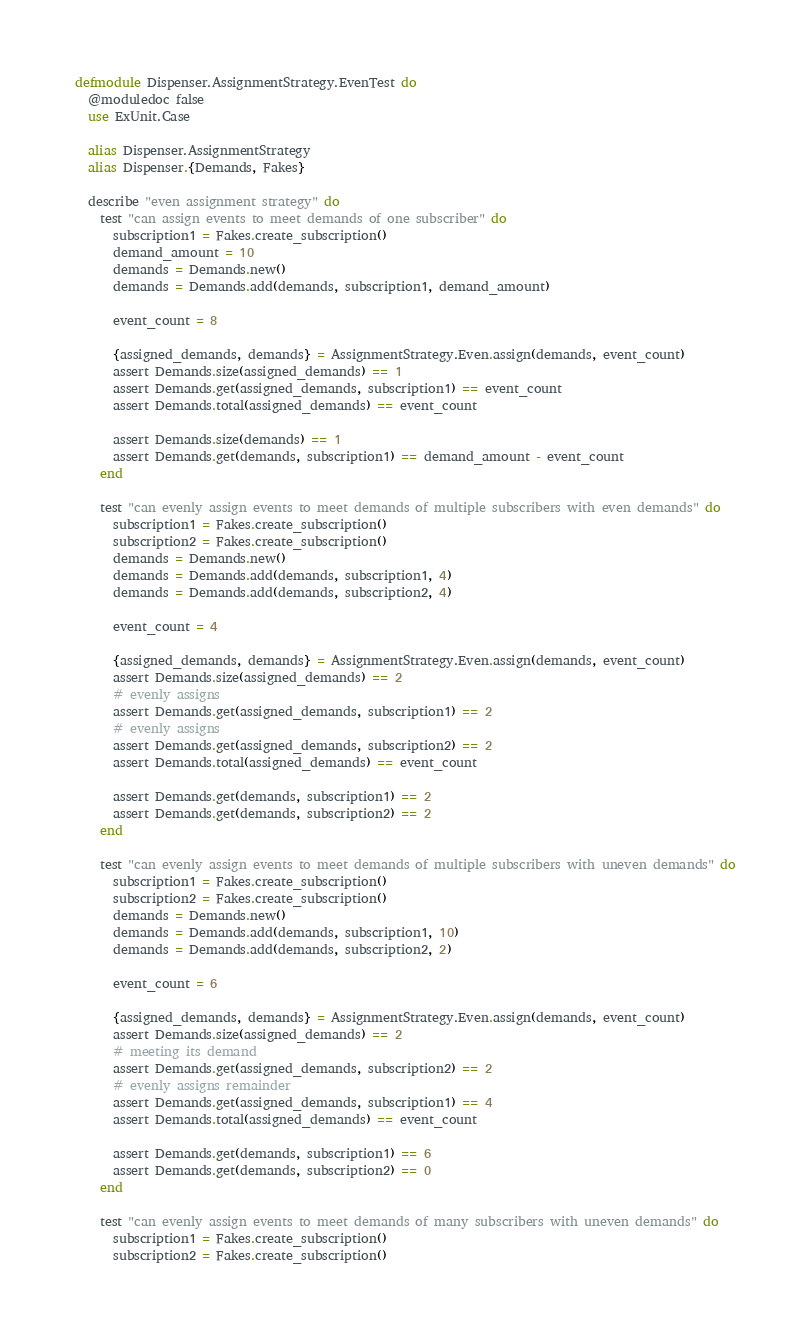<code> <loc_0><loc_0><loc_500><loc_500><_Elixir_>defmodule Dispenser.AssignmentStrategy.EvenTest do
  @moduledoc false
  use ExUnit.Case

  alias Dispenser.AssignmentStrategy
  alias Dispenser.{Demands, Fakes}

  describe "even assignment strategy" do
    test "can assign events to meet demands of one subscriber" do
      subscription1 = Fakes.create_subscription()
      demand_amount = 10
      demands = Demands.new()
      demands = Demands.add(demands, subscription1, demand_amount)

      event_count = 8

      {assigned_demands, demands} = AssignmentStrategy.Even.assign(demands, event_count)
      assert Demands.size(assigned_demands) == 1
      assert Demands.get(assigned_demands, subscription1) == event_count
      assert Demands.total(assigned_demands) == event_count

      assert Demands.size(demands) == 1
      assert Demands.get(demands, subscription1) == demand_amount - event_count
    end

    test "can evenly assign events to meet demands of multiple subscribers with even demands" do
      subscription1 = Fakes.create_subscription()
      subscription2 = Fakes.create_subscription()
      demands = Demands.new()
      demands = Demands.add(demands, subscription1, 4)
      demands = Demands.add(demands, subscription2, 4)

      event_count = 4

      {assigned_demands, demands} = AssignmentStrategy.Even.assign(demands, event_count)
      assert Demands.size(assigned_demands) == 2
      # evenly assigns
      assert Demands.get(assigned_demands, subscription1) == 2
      # evenly assigns
      assert Demands.get(assigned_demands, subscription2) == 2
      assert Demands.total(assigned_demands) == event_count

      assert Demands.get(demands, subscription1) == 2
      assert Demands.get(demands, subscription2) == 2
    end

    test "can evenly assign events to meet demands of multiple subscribers with uneven demands" do
      subscription1 = Fakes.create_subscription()
      subscription2 = Fakes.create_subscription()
      demands = Demands.new()
      demands = Demands.add(demands, subscription1, 10)
      demands = Demands.add(demands, subscription2, 2)

      event_count = 6

      {assigned_demands, demands} = AssignmentStrategy.Even.assign(demands, event_count)
      assert Demands.size(assigned_demands) == 2
      # meeting its demand
      assert Demands.get(assigned_demands, subscription2) == 2
      # evenly assigns remainder
      assert Demands.get(assigned_demands, subscription1) == 4
      assert Demands.total(assigned_demands) == event_count

      assert Demands.get(demands, subscription1) == 6
      assert Demands.get(demands, subscription2) == 0
    end

    test "can evenly assign events to meet demands of many subscribers with uneven demands" do
      subscription1 = Fakes.create_subscription()
      subscription2 = Fakes.create_subscription()</code> 